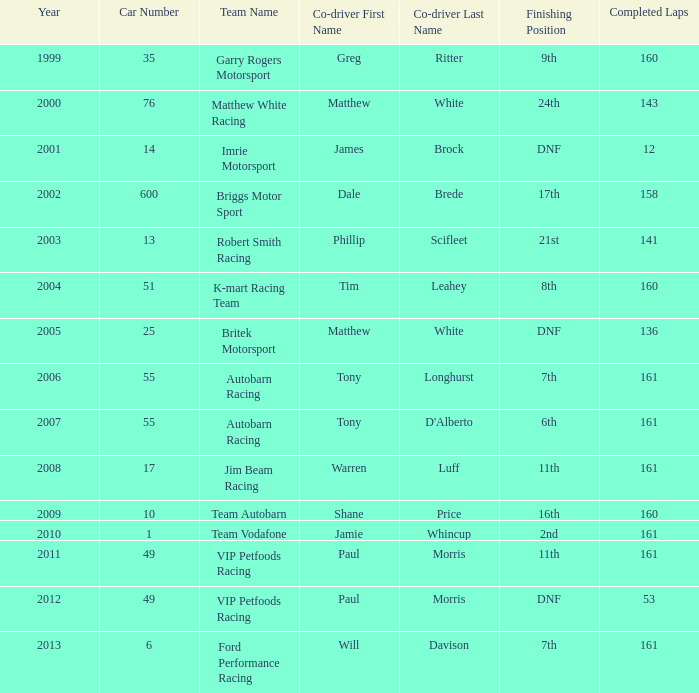I'm looking to parse the entire table for insights. Could you assist me with that? {'header': ['Year', 'Car Number', 'Team Name', 'Co-driver First Name', 'Co-driver Last Name', 'Finishing Position', 'Completed Laps'], 'rows': [['1999', '35', 'Garry Rogers Motorsport', 'Greg', 'Ritter', '9th', '160'], ['2000', '76', 'Matthew White Racing', 'Matthew', 'White', '24th', '143'], ['2001', '14', 'Imrie Motorsport', 'James', 'Brock', 'DNF', '12'], ['2002', '600', 'Briggs Motor Sport', 'Dale', 'Brede', '17th', '158'], ['2003', '13', 'Robert Smith Racing', 'Phillip', 'Scifleet', '21st', '141'], ['2004', '51', 'K-mart Racing Team', 'Tim', 'Leahey', '8th', '160'], ['2005', '25', 'Britek Motorsport', 'Matthew', 'White', 'DNF', '136'], ['2006', '55', 'Autobarn Racing', 'Tony', 'Longhurst', '7th', '161'], ['2007', '55', 'Autobarn Racing', 'Tony', "D'Alberto", '6th', '161'], ['2008', '17', 'Jim Beam Racing', 'Warren', 'Luff', '11th', '161'], ['2009', '10', 'Team Autobarn', 'Shane', 'Price', '16th', '160'], ['2010', '1', 'Team Vodafone', 'Jamie', 'Whincup', '2nd', '161'], ['2011', '49', 'VIP Petfoods Racing', 'Paul', 'Morris', '11th', '161'], ['2012', '49', 'VIP Petfoods Racing', 'Paul', 'Morris', 'DNF', '53'], ['2013', '6', 'Ford Performance Racing', 'Will', 'Davison', '7th', '161']]} What is the fewest laps for a team with a position of DNF and a number smaller than 25 before 2001? None. 